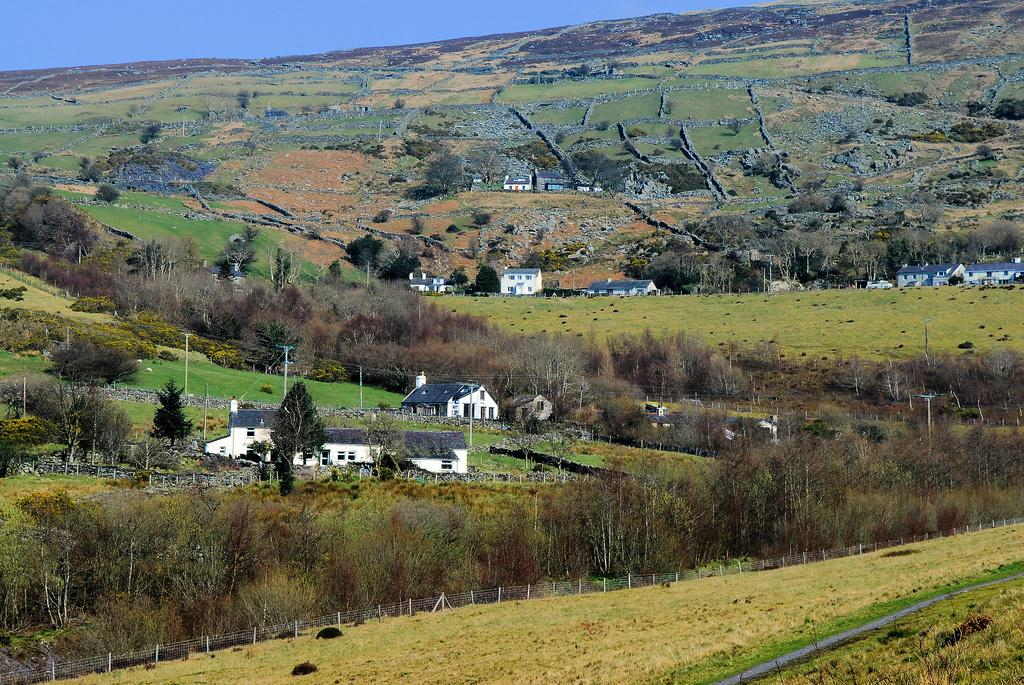What type of barrier can be seen in the image? There is a fence in the image. What is located behind the fence? There are trees and houses behind the fence. What structures are present in the image? There are poles in the image. What natural feature is visible in the image? There is a hill visible in the image. What part of the environment is visible in the image? The sky is visible in the image. What type of cake is being served on the hill in the image? There is no cake present in the image; it features a fence, trees, houses, poles, a hill, and the sky. What type of wool is being used to decorate the poles in the image? There is no wool present in the image; the poles are not decorated. 